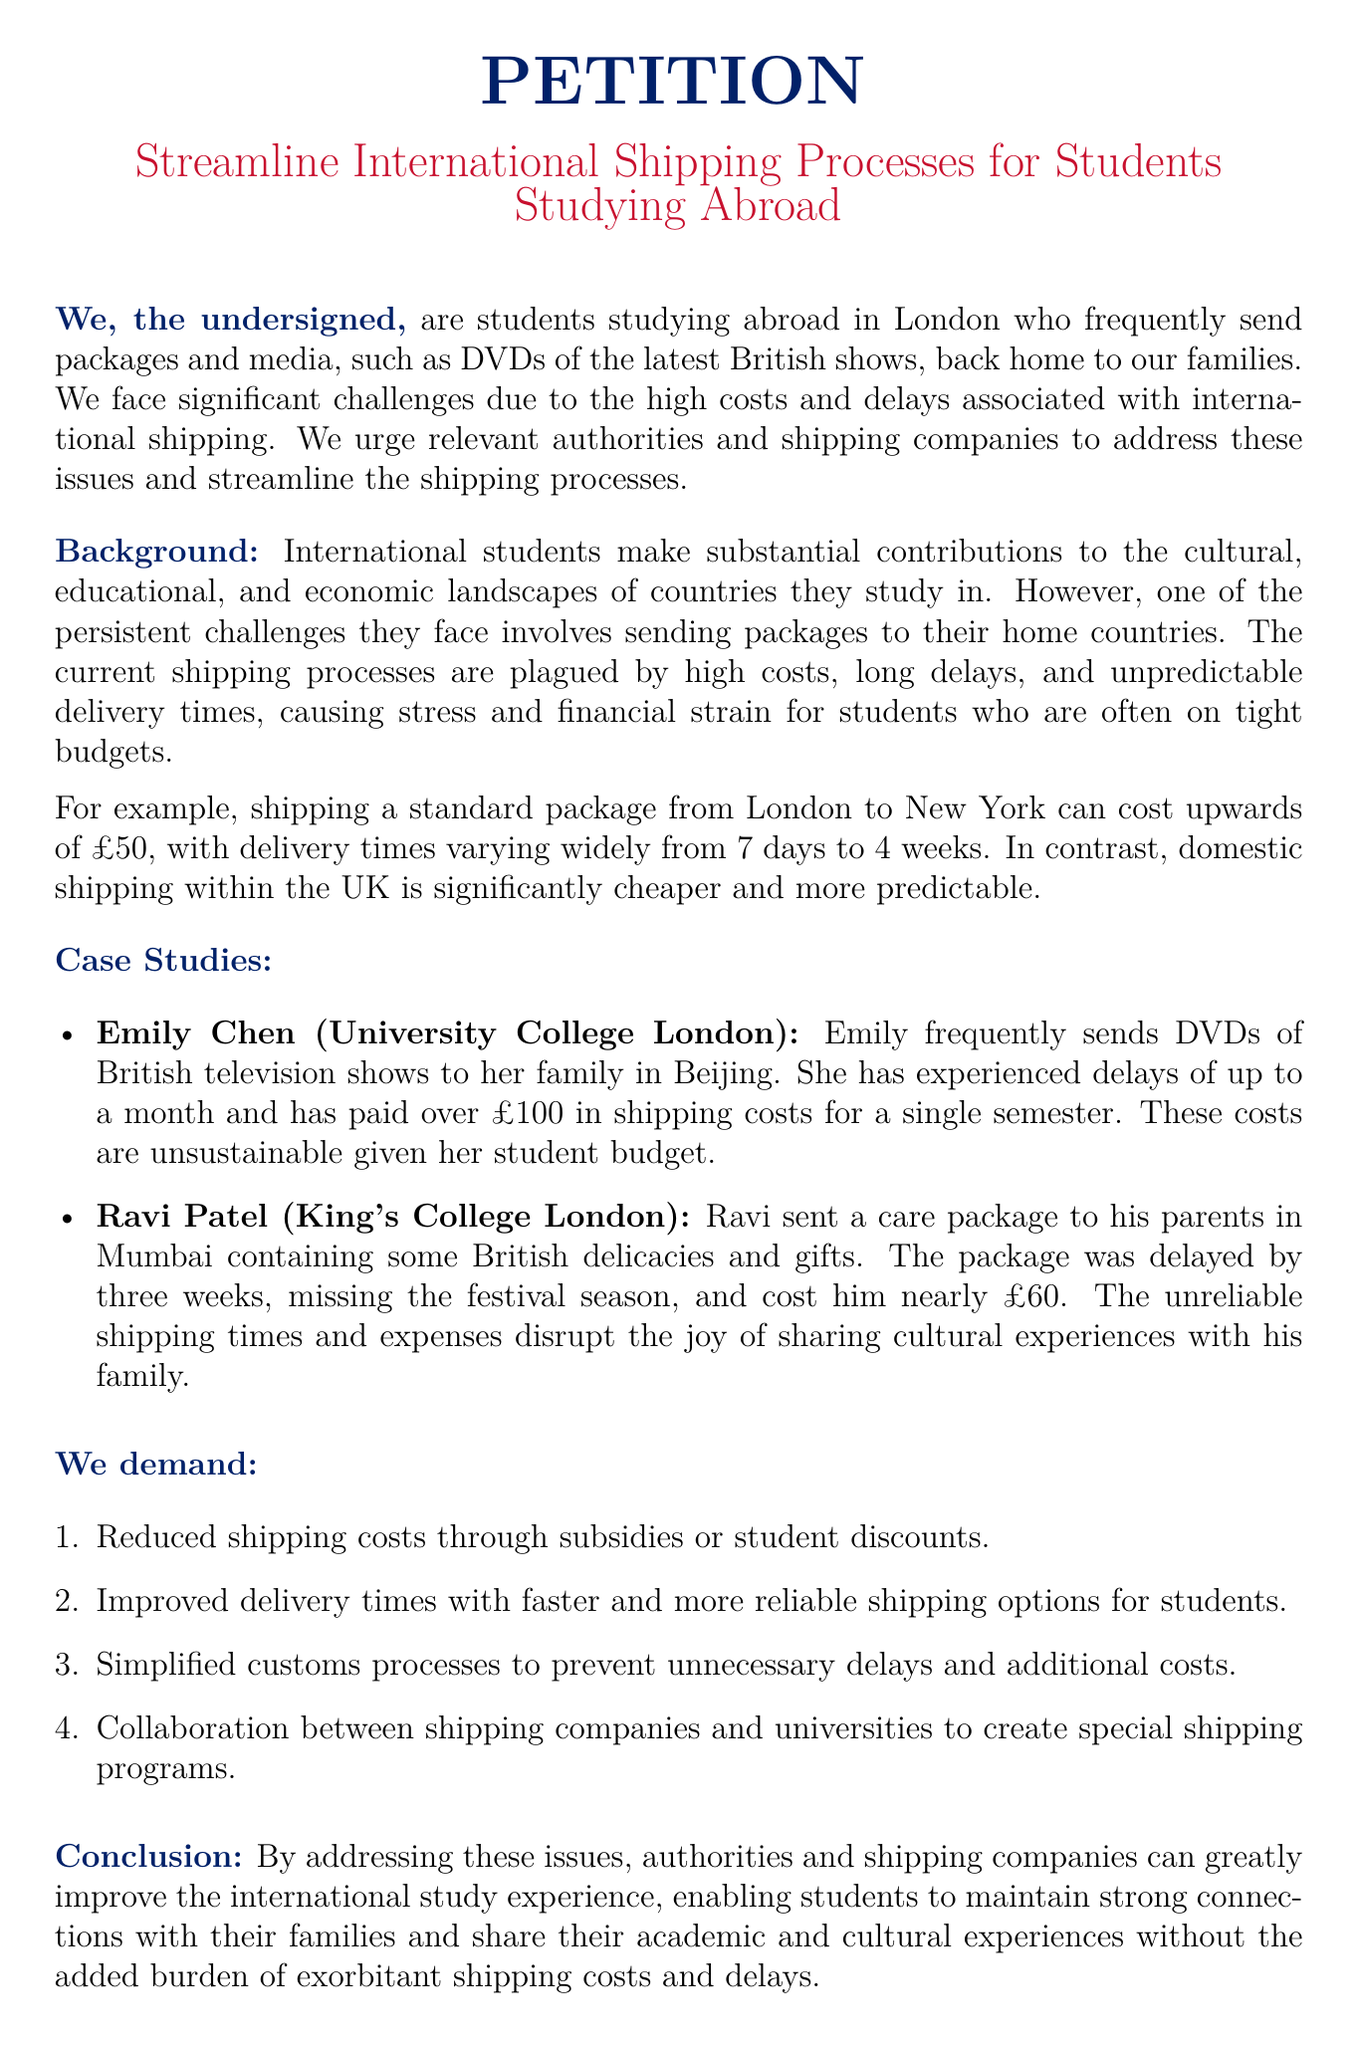What is the title of the petition? The title is mentioned prominently at the beginning of the document.
Answer: Streamline International Shipping Processes for Students Studying Abroad Who is the petition aimed at? The document states the target audience for the petition.
Answer: Relevant authorities and shipping companies What is one major challenge faced by international students? The document identifies key issues faced by students studying abroad.
Answer: High costs How much did Emily Chen pay in shipping costs for a single semester? The example provides specific financial details related to a student's experience.
Answer: Over £100 What is a proposed demand related to shipping costs? The demands list actions to be taken regarding shipping costs.
Answer: Reduced shipping costs through subsidies or student discounts What is the estimated cost to ship a standard package from London to New York? The document provides a specific figure regarding shipping costs.
Answer: £50 What type of items does Ravi Patel include in his care package? The case study mentions specific contents of Ravi's package.
Answer: British delicacies and gifts What duration can shipping times vary for packages sent to New York? The document includes a range for the duration of delivery times.
Answer: 7 days to 4 weeks What is the main goal of the petition? The last paragraph summarizes the overall intent behind the petition.
Answer: Improve the international study experience 